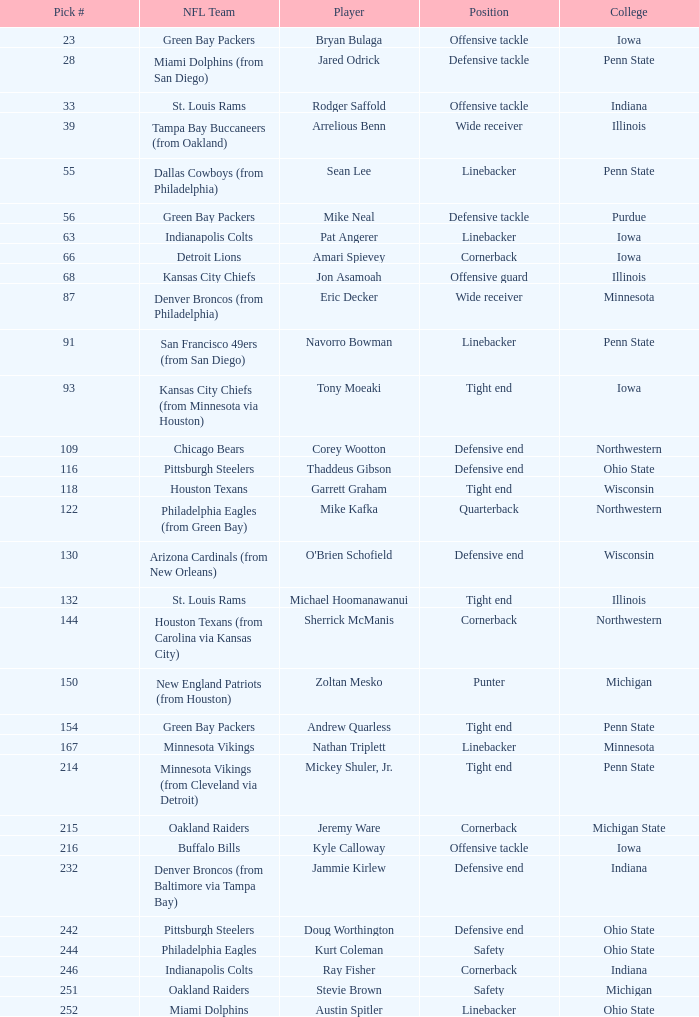What was sherrick mcmanis's initial round? 5.0. Parse the full table. {'header': ['Pick #', 'NFL Team', 'Player', 'Position', 'College'], 'rows': [['23', 'Green Bay Packers', 'Bryan Bulaga', 'Offensive tackle', 'Iowa'], ['28', 'Miami Dolphins (from San Diego)', 'Jared Odrick', 'Defensive tackle', 'Penn State'], ['33', 'St. Louis Rams', 'Rodger Saffold', 'Offensive tackle', 'Indiana'], ['39', 'Tampa Bay Buccaneers (from Oakland)', 'Arrelious Benn', 'Wide receiver', 'Illinois'], ['55', 'Dallas Cowboys (from Philadelphia)', 'Sean Lee', 'Linebacker', 'Penn State'], ['56', 'Green Bay Packers', 'Mike Neal', 'Defensive tackle', 'Purdue'], ['63', 'Indianapolis Colts', 'Pat Angerer', 'Linebacker', 'Iowa'], ['66', 'Detroit Lions', 'Amari Spievey', 'Cornerback', 'Iowa'], ['68', 'Kansas City Chiefs', 'Jon Asamoah', 'Offensive guard', 'Illinois'], ['87', 'Denver Broncos (from Philadelphia)', 'Eric Decker', 'Wide receiver', 'Minnesota'], ['91', 'San Francisco 49ers (from San Diego)', 'Navorro Bowman', 'Linebacker', 'Penn State'], ['93', 'Kansas City Chiefs (from Minnesota via Houston)', 'Tony Moeaki', 'Tight end', 'Iowa'], ['109', 'Chicago Bears', 'Corey Wootton', 'Defensive end', 'Northwestern'], ['116', 'Pittsburgh Steelers', 'Thaddeus Gibson', 'Defensive end', 'Ohio State'], ['118', 'Houston Texans', 'Garrett Graham', 'Tight end', 'Wisconsin'], ['122', 'Philadelphia Eagles (from Green Bay)', 'Mike Kafka', 'Quarterback', 'Northwestern'], ['130', 'Arizona Cardinals (from New Orleans)', "O'Brien Schofield", 'Defensive end', 'Wisconsin'], ['132', 'St. Louis Rams', 'Michael Hoomanawanui', 'Tight end', 'Illinois'], ['144', 'Houston Texans (from Carolina via Kansas City)', 'Sherrick McManis', 'Cornerback', 'Northwestern'], ['150', 'New England Patriots (from Houston)', 'Zoltan Mesko', 'Punter', 'Michigan'], ['154', 'Green Bay Packers', 'Andrew Quarless', 'Tight end', 'Penn State'], ['167', 'Minnesota Vikings', 'Nathan Triplett', 'Linebacker', 'Minnesota'], ['214', 'Minnesota Vikings (from Cleveland via Detroit)', 'Mickey Shuler, Jr.', 'Tight end', 'Penn State'], ['215', 'Oakland Raiders', 'Jeremy Ware', 'Cornerback', 'Michigan State'], ['216', 'Buffalo Bills', 'Kyle Calloway', 'Offensive tackle', 'Iowa'], ['232', 'Denver Broncos (from Baltimore via Tampa Bay)', 'Jammie Kirlew', 'Defensive end', 'Indiana'], ['242', 'Pittsburgh Steelers', 'Doug Worthington', 'Defensive end', 'Ohio State'], ['244', 'Philadelphia Eagles', 'Kurt Coleman', 'Safety', 'Ohio State'], ['246', 'Indianapolis Colts', 'Ray Fisher', 'Cornerback', 'Indiana'], ['251', 'Oakland Raiders', 'Stevie Brown', 'Safety', 'Michigan'], ['252', 'Miami Dolphins', 'Austin Spitler', 'Linebacker', 'Ohio State']]} 